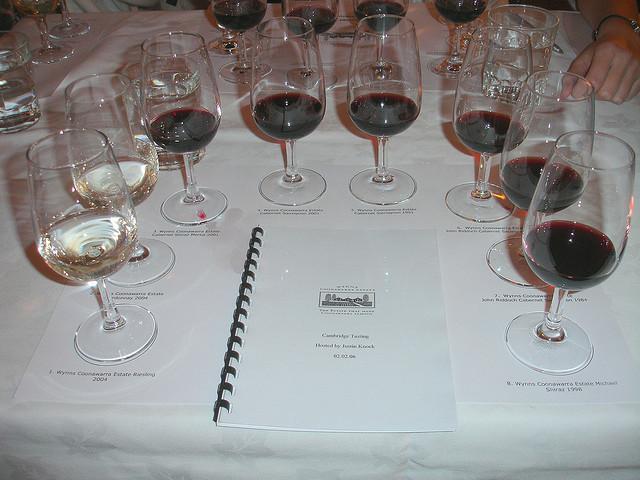How many glasses are on the table?
Give a very brief answer. 8. How many glasses are there?
Keep it brief. 8. What does it say on the menu?
Short answer required. Wine. Is the tablecloth straight or wrinkled?
Give a very brief answer. Straight. How many glasses have red wine?
Concise answer only. 10. 